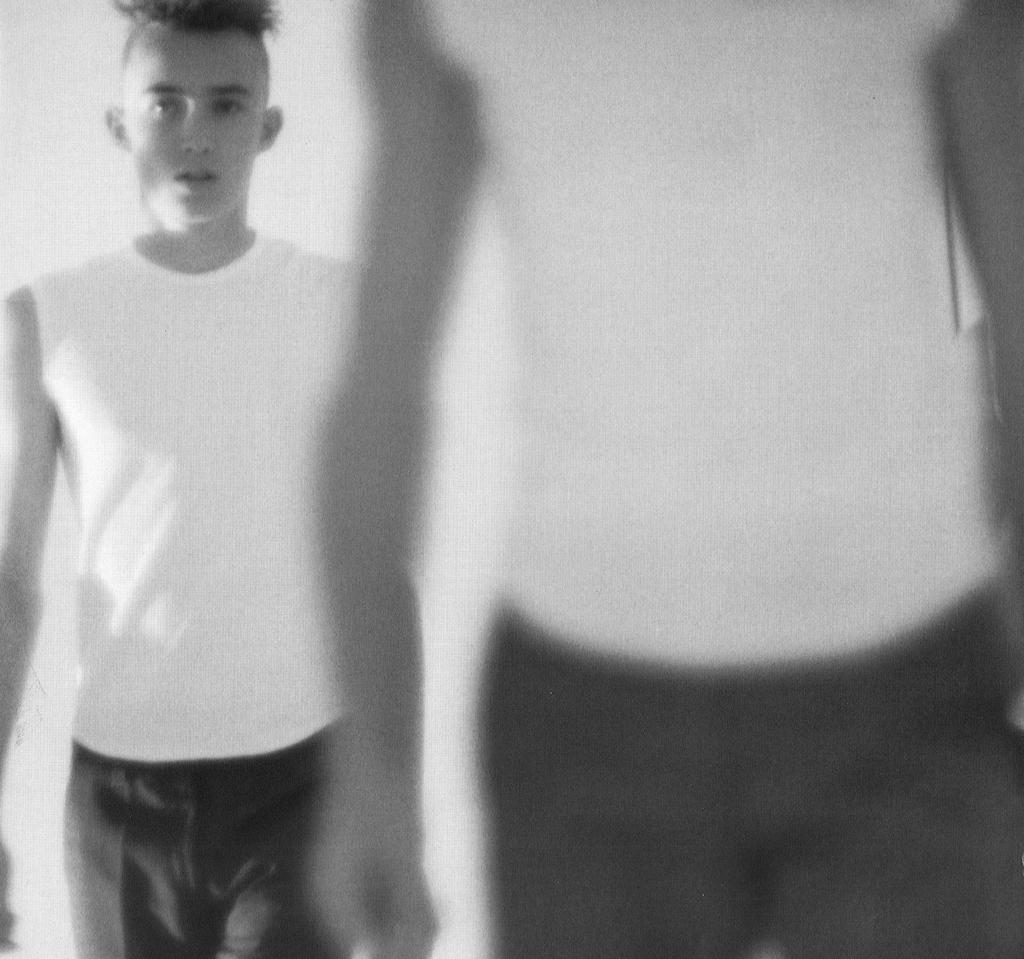What is the color scheme of the image? The image is black and white. How many people are in the image? There are two persons in the image. What are the persons wearing? Both persons are wearing white t-shirts. What are the persons doing in the image? The persons appear to be walking. What type of note is the person holding in the image? There is no note visible in the image; the persons are only wearing white t-shirts and walking. Is there a gun present in the image? No, there is no gun present in the image. 